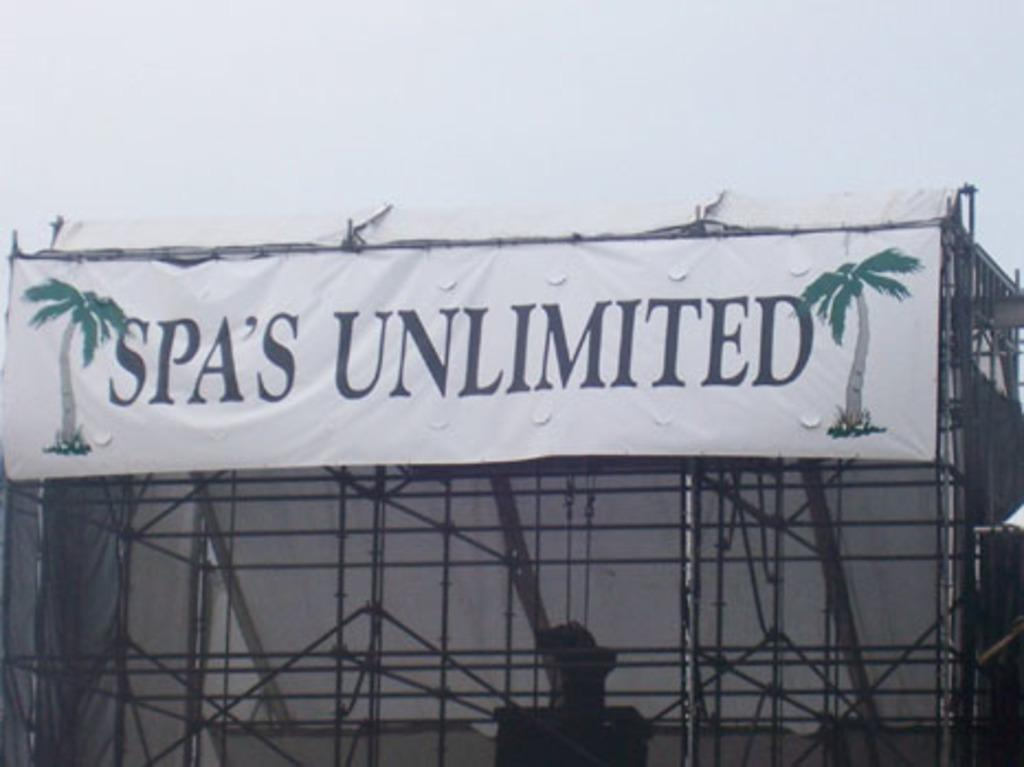<image>
Create a compact narrative representing the image presented. a sign that has spa's unlimited on the front 